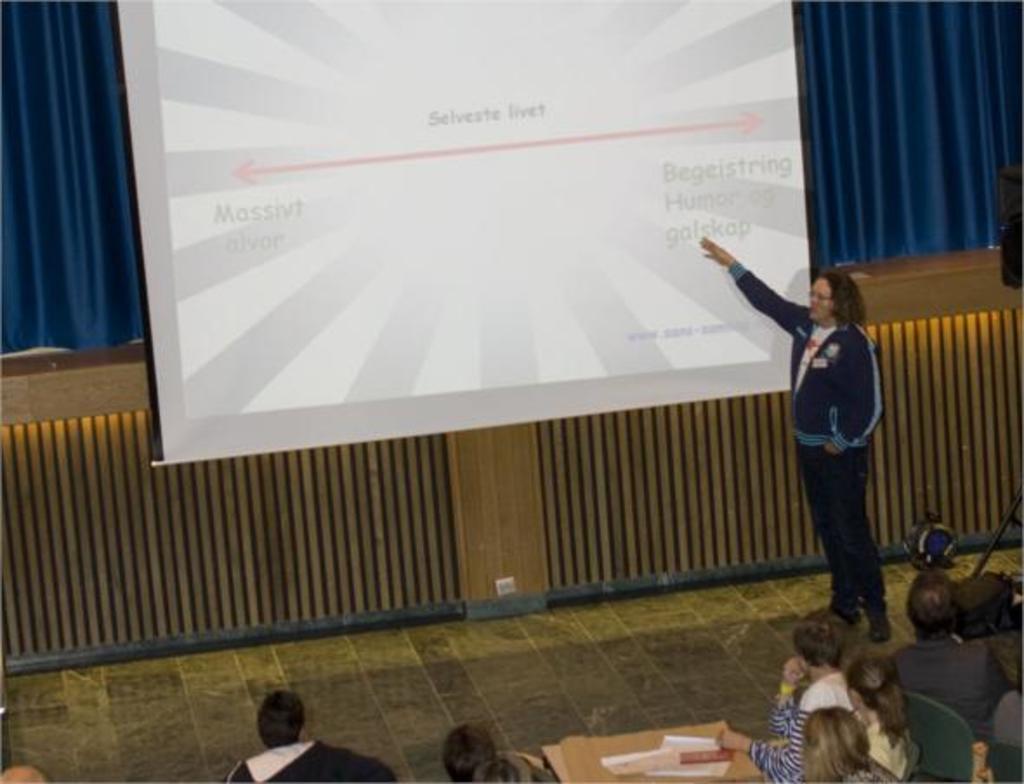Describe this image in one or two sentences. In this image we can see a few people sitting on the chairs and also we can see a person standing on the floor, there is a screen with some text, on the floor there is a table with some objects and in the background, we can see a curtain. 